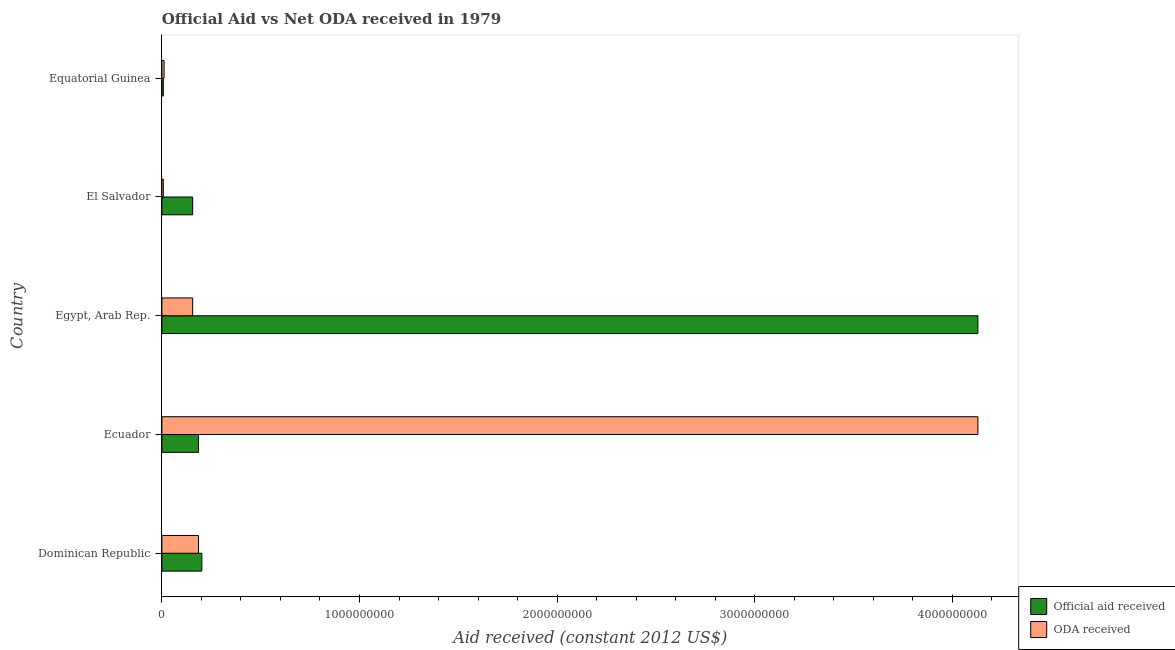How many different coloured bars are there?
Offer a very short reply. 2. How many groups of bars are there?
Offer a very short reply. 5. Are the number of bars on each tick of the Y-axis equal?
Offer a terse response. Yes. How many bars are there on the 4th tick from the bottom?
Your answer should be very brief. 2. What is the label of the 4th group of bars from the top?
Ensure brevity in your answer.  Ecuador. In how many cases, is the number of bars for a given country not equal to the number of legend labels?
Provide a short and direct response. 0. What is the official aid received in Egypt, Arab Rep.?
Provide a short and direct response. 4.13e+09. Across all countries, what is the maximum oda received?
Provide a short and direct response. 4.13e+09. Across all countries, what is the minimum oda received?
Provide a short and direct response. 7.13e+06. In which country was the oda received maximum?
Ensure brevity in your answer.  Ecuador. In which country was the official aid received minimum?
Your answer should be very brief. Equatorial Guinea. What is the total official aid received in the graph?
Offer a very short reply. 4.68e+09. What is the difference between the official aid received in Dominican Republic and that in Equatorial Guinea?
Give a very brief answer. 1.95e+08. What is the difference between the oda received in Dominican Republic and the official aid received in Egypt, Arab Rep.?
Your answer should be compact. -3.94e+09. What is the average official aid received per country?
Offer a terse response. 9.36e+08. What is the difference between the official aid received and oda received in Ecuador?
Give a very brief answer. -3.94e+09. What is the ratio of the official aid received in El Salvador to that in Equatorial Guinea?
Provide a short and direct response. 21.83. What is the difference between the highest and the second highest oda received?
Your response must be concise. 3.94e+09. What is the difference between the highest and the lowest oda received?
Ensure brevity in your answer.  4.12e+09. In how many countries, is the official aid received greater than the average official aid received taken over all countries?
Ensure brevity in your answer.  1. Is the sum of the oda received in Egypt, Arab Rep. and Equatorial Guinea greater than the maximum official aid received across all countries?
Your response must be concise. No. What does the 2nd bar from the top in Egypt, Arab Rep. represents?
Offer a terse response. Official aid received. What does the 1st bar from the bottom in Equatorial Guinea represents?
Give a very brief answer. Official aid received. How many countries are there in the graph?
Your answer should be very brief. 5. Are the values on the major ticks of X-axis written in scientific E-notation?
Provide a succinct answer. No. Where does the legend appear in the graph?
Your response must be concise. Bottom right. How are the legend labels stacked?
Keep it short and to the point. Vertical. What is the title of the graph?
Provide a succinct answer. Official Aid vs Net ODA received in 1979 . What is the label or title of the X-axis?
Provide a short and direct response. Aid received (constant 2012 US$). What is the Aid received (constant 2012 US$) in Official aid received in Dominican Republic?
Offer a terse response. 2.02e+08. What is the Aid received (constant 2012 US$) of ODA received in Dominican Republic?
Keep it short and to the point. 1.85e+08. What is the Aid received (constant 2012 US$) in Official aid received in Ecuador?
Ensure brevity in your answer.  1.85e+08. What is the Aid received (constant 2012 US$) of ODA received in Ecuador?
Your response must be concise. 4.13e+09. What is the Aid received (constant 2012 US$) in Official aid received in Egypt, Arab Rep.?
Provide a succinct answer. 4.13e+09. What is the Aid received (constant 2012 US$) in ODA received in Egypt, Arab Rep.?
Make the answer very short. 1.56e+08. What is the Aid received (constant 2012 US$) of Official aid received in El Salvador?
Your answer should be very brief. 1.56e+08. What is the Aid received (constant 2012 US$) in ODA received in El Salvador?
Offer a very short reply. 7.13e+06. What is the Aid received (constant 2012 US$) of Official aid received in Equatorial Guinea?
Make the answer very short. 7.13e+06. What is the Aid received (constant 2012 US$) in ODA received in Equatorial Guinea?
Give a very brief answer. 1.10e+07. Across all countries, what is the maximum Aid received (constant 2012 US$) of Official aid received?
Offer a very short reply. 4.13e+09. Across all countries, what is the maximum Aid received (constant 2012 US$) of ODA received?
Provide a succinct answer. 4.13e+09. Across all countries, what is the minimum Aid received (constant 2012 US$) of Official aid received?
Ensure brevity in your answer.  7.13e+06. Across all countries, what is the minimum Aid received (constant 2012 US$) in ODA received?
Offer a terse response. 7.13e+06. What is the total Aid received (constant 2012 US$) of Official aid received in the graph?
Provide a short and direct response. 4.68e+09. What is the total Aid received (constant 2012 US$) of ODA received in the graph?
Provide a succinct answer. 4.49e+09. What is the difference between the Aid received (constant 2012 US$) in Official aid received in Dominican Republic and that in Ecuador?
Make the answer very short. 1.70e+07. What is the difference between the Aid received (constant 2012 US$) in ODA received in Dominican Republic and that in Ecuador?
Your response must be concise. -3.94e+09. What is the difference between the Aid received (constant 2012 US$) of Official aid received in Dominican Republic and that in Egypt, Arab Rep.?
Offer a terse response. -3.93e+09. What is the difference between the Aid received (constant 2012 US$) in ODA received in Dominican Republic and that in Egypt, Arab Rep.?
Give a very brief answer. 2.95e+07. What is the difference between the Aid received (constant 2012 US$) in Official aid received in Dominican Republic and that in El Salvador?
Ensure brevity in your answer.  4.65e+07. What is the difference between the Aid received (constant 2012 US$) in ODA received in Dominican Republic and that in El Salvador?
Keep it short and to the point. 1.78e+08. What is the difference between the Aid received (constant 2012 US$) in Official aid received in Dominican Republic and that in Equatorial Guinea?
Offer a very short reply. 1.95e+08. What is the difference between the Aid received (constant 2012 US$) in ODA received in Dominican Republic and that in Equatorial Guinea?
Make the answer very short. 1.74e+08. What is the difference between the Aid received (constant 2012 US$) of Official aid received in Ecuador and that in Egypt, Arab Rep.?
Give a very brief answer. -3.94e+09. What is the difference between the Aid received (constant 2012 US$) in ODA received in Ecuador and that in Egypt, Arab Rep.?
Offer a terse response. 3.97e+09. What is the difference between the Aid received (constant 2012 US$) of Official aid received in Ecuador and that in El Salvador?
Your response must be concise. 2.95e+07. What is the difference between the Aid received (constant 2012 US$) in ODA received in Ecuador and that in El Salvador?
Make the answer very short. 4.12e+09. What is the difference between the Aid received (constant 2012 US$) in Official aid received in Ecuador and that in Equatorial Guinea?
Provide a succinct answer. 1.78e+08. What is the difference between the Aid received (constant 2012 US$) of ODA received in Ecuador and that in Equatorial Guinea?
Your response must be concise. 4.12e+09. What is the difference between the Aid received (constant 2012 US$) in Official aid received in Egypt, Arab Rep. and that in El Salvador?
Offer a terse response. 3.97e+09. What is the difference between the Aid received (constant 2012 US$) in ODA received in Egypt, Arab Rep. and that in El Salvador?
Make the answer very short. 1.49e+08. What is the difference between the Aid received (constant 2012 US$) in Official aid received in Egypt, Arab Rep. and that in Equatorial Guinea?
Your answer should be very brief. 4.12e+09. What is the difference between the Aid received (constant 2012 US$) in ODA received in Egypt, Arab Rep. and that in Equatorial Guinea?
Your response must be concise. 1.45e+08. What is the difference between the Aid received (constant 2012 US$) of Official aid received in El Salvador and that in Equatorial Guinea?
Your answer should be compact. 1.49e+08. What is the difference between the Aid received (constant 2012 US$) in ODA received in El Salvador and that in Equatorial Guinea?
Make the answer very short. -3.86e+06. What is the difference between the Aid received (constant 2012 US$) in Official aid received in Dominican Republic and the Aid received (constant 2012 US$) in ODA received in Ecuador?
Your answer should be compact. -3.93e+09. What is the difference between the Aid received (constant 2012 US$) of Official aid received in Dominican Republic and the Aid received (constant 2012 US$) of ODA received in Egypt, Arab Rep.?
Make the answer very short. 4.65e+07. What is the difference between the Aid received (constant 2012 US$) of Official aid received in Dominican Republic and the Aid received (constant 2012 US$) of ODA received in El Salvador?
Offer a terse response. 1.95e+08. What is the difference between the Aid received (constant 2012 US$) of Official aid received in Dominican Republic and the Aid received (constant 2012 US$) of ODA received in Equatorial Guinea?
Provide a short and direct response. 1.91e+08. What is the difference between the Aid received (constant 2012 US$) in Official aid received in Ecuador and the Aid received (constant 2012 US$) in ODA received in Egypt, Arab Rep.?
Your answer should be compact. 2.95e+07. What is the difference between the Aid received (constant 2012 US$) in Official aid received in Ecuador and the Aid received (constant 2012 US$) in ODA received in El Salvador?
Offer a very short reply. 1.78e+08. What is the difference between the Aid received (constant 2012 US$) in Official aid received in Ecuador and the Aid received (constant 2012 US$) in ODA received in Equatorial Guinea?
Your answer should be compact. 1.74e+08. What is the difference between the Aid received (constant 2012 US$) in Official aid received in Egypt, Arab Rep. and the Aid received (constant 2012 US$) in ODA received in El Salvador?
Make the answer very short. 4.12e+09. What is the difference between the Aid received (constant 2012 US$) of Official aid received in Egypt, Arab Rep. and the Aid received (constant 2012 US$) of ODA received in Equatorial Guinea?
Provide a succinct answer. 4.12e+09. What is the difference between the Aid received (constant 2012 US$) of Official aid received in El Salvador and the Aid received (constant 2012 US$) of ODA received in Equatorial Guinea?
Your answer should be very brief. 1.45e+08. What is the average Aid received (constant 2012 US$) in Official aid received per country?
Provide a short and direct response. 9.36e+08. What is the average Aid received (constant 2012 US$) of ODA received per country?
Offer a terse response. 8.98e+08. What is the difference between the Aid received (constant 2012 US$) in Official aid received and Aid received (constant 2012 US$) in ODA received in Dominican Republic?
Your response must be concise. 1.70e+07. What is the difference between the Aid received (constant 2012 US$) of Official aid received and Aid received (constant 2012 US$) of ODA received in Ecuador?
Keep it short and to the point. -3.94e+09. What is the difference between the Aid received (constant 2012 US$) in Official aid received and Aid received (constant 2012 US$) in ODA received in Egypt, Arab Rep.?
Your response must be concise. 3.97e+09. What is the difference between the Aid received (constant 2012 US$) of Official aid received and Aid received (constant 2012 US$) of ODA received in El Salvador?
Ensure brevity in your answer.  1.49e+08. What is the difference between the Aid received (constant 2012 US$) of Official aid received and Aid received (constant 2012 US$) of ODA received in Equatorial Guinea?
Ensure brevity in your answer.  -3.86e+06. What is the ratio of the Aid received (constant 2012 US$) in Official aid received in Dominican Republic to that in Ecuador?
Keep it short and to the point. 1.09. What is the ratio of the Aid received (constant 2012 US$) in ODA received in Dominican Republic to that in Ecuador?
Ensure brevity in your answer.  0.04. What is the ratio of the Aid received (constant 2012 US$) in Official aid received in Dominican Republic to that in Egypt, Arab Rep.?
Your answer should be very brief. 0.05. What is the ratio of the Aid received (constant 2012 US$) of ODA received in Dominican Republic to that in Egypt, Arab Rep.?
Your answer should be very brief. 1.19. What is the ratio of the Aid received (constant 2012 US$) of Official aid received in Dominican Republic to that in El Salvador?
Offer a very short reply. 1.3. What is the ratio of the Aid received (constant 2012 US$) in ODA received in Dominican Republic to that in El Salvador?
Keep it short and to the point. 25.97. What is the ratio of the Aid received (constant 2012 US$) in Official aid received in Dominican Republic to that in Equatorial Guinea?
Ensure brevity in your answer.  28.35. What is the ratio of the Aid received (constant 2012 US$) of ODA received in Dominican Republic to that in Equatorial Guinea?
Keep it short and to the point. 16.85. What is the ratio of the Aid received (constant 2012 US$) in Official aid received in Ecuador to that in Egypt, Arab Rep.?
Ensure brevity in your answer.  0.04. What is the ratio of the Aid received (constant 2012 US$) of ODA received in Ecuador to that in Egypt, Arab Rep.?
Provide a short and direct response. 26.53. What is the ratio of the Aid received (constant 2012 US$) in Official aid received in Ecuador to that in El Salvador?
Provide a succinct answer. 1.19. What is the ratio of the Aid received (constant 2012 US$) of ODA received in Ecuador to that in El Salvador?
Offer a very short reply. 579.19. What is the ratio of the Aid received (constant 2012 US$) of Official aid received in Ecuador to that in Equatorial Guinea?
Provide a short and direct response. 25.97. What is the ratio of the Aid received (constant 2012 US$) in ODA received in Ecuador to that in Equatorial Guinea?
Provide a short and direct response. 375.76. What is the ratio of the Aid received (constant 2012 US$) in Official aid received in Egypt, Arab Rep. to that in El Salvador?
Give a very brief answer. 26.53. What is the ratio of the Aid received (constant 2012 US$) in ODA received in Egypt, Arab Rep. to that in El Salvador?
Offer a terse response. 21.83. What is the ratio of the Aid received (constant 2012 US$) in Official aid received in Egypt, Arab Rep. to that in Equatorial Guinea?
Provide a succinct answer. 579.19. What is the ratio of the Aid received (constant 2012 US$) in ODA received in Egypt, Arab Rep. to that in Equatorial Guinea?
Ensure brevity in your answer.  14.16. What is the ratio of the Aid received (constant 2012 US$) in Official aid received in El Salvador to that in Equatorial Guinea?
Your answer should be very brief. 21.83. What is the ratio of the Aid received (constant 2012 US$) of ODA received in El Salvador to that in Equatorial Guinea?
Ensure brevity in your answer.  0.65. What is the difference between the highest and the second highest Aid received (constant 2012 US$) of Official aid received?
Your response must be concise. 3.93e+09. What is the difference between the highest and the second highest Aid received (constant 2012 US$) in ODA received?
Ensure brevity in your answer.  3.94e+09. What is the difference between the highest and the lowest Aid received (constant 2012 US$) in Official aid received?
Offer a terse response. 4.12e+09. What is the difference between the highest and the lowest Aid received (constant 2012 US$) of ODA received?
Provide a short and direct response. 4.12e+09. 